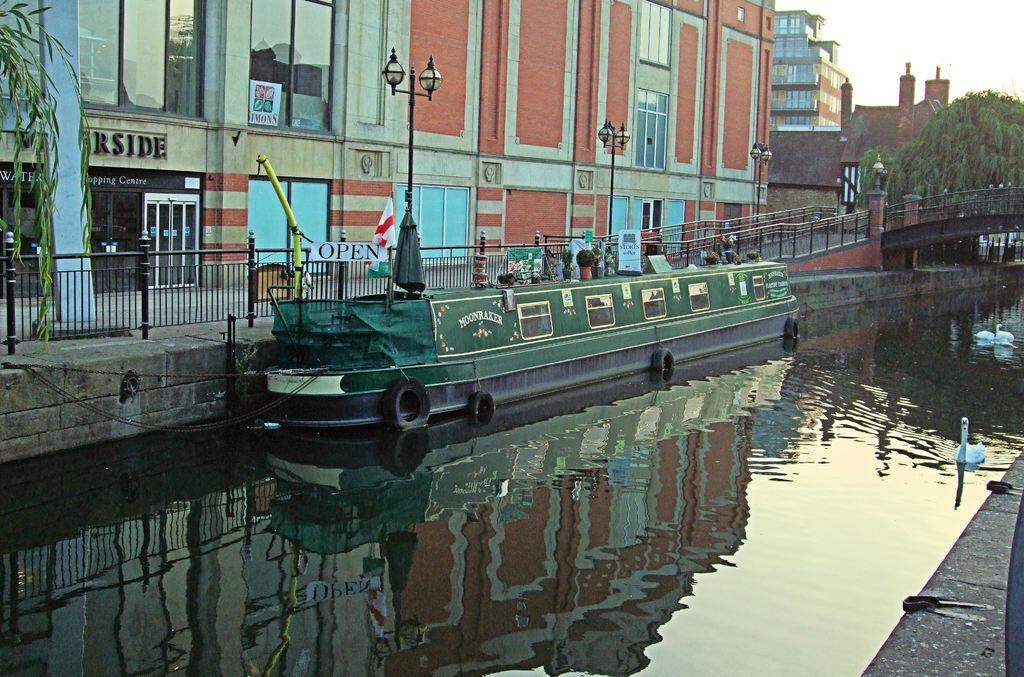In one or two sentences, can you explain what this image depicts? In this image I can see the water, a boat which is black and green color on the surface of the water and few animals. In the background I can see the railing, few buildings, few poles, few trees and the sky. 